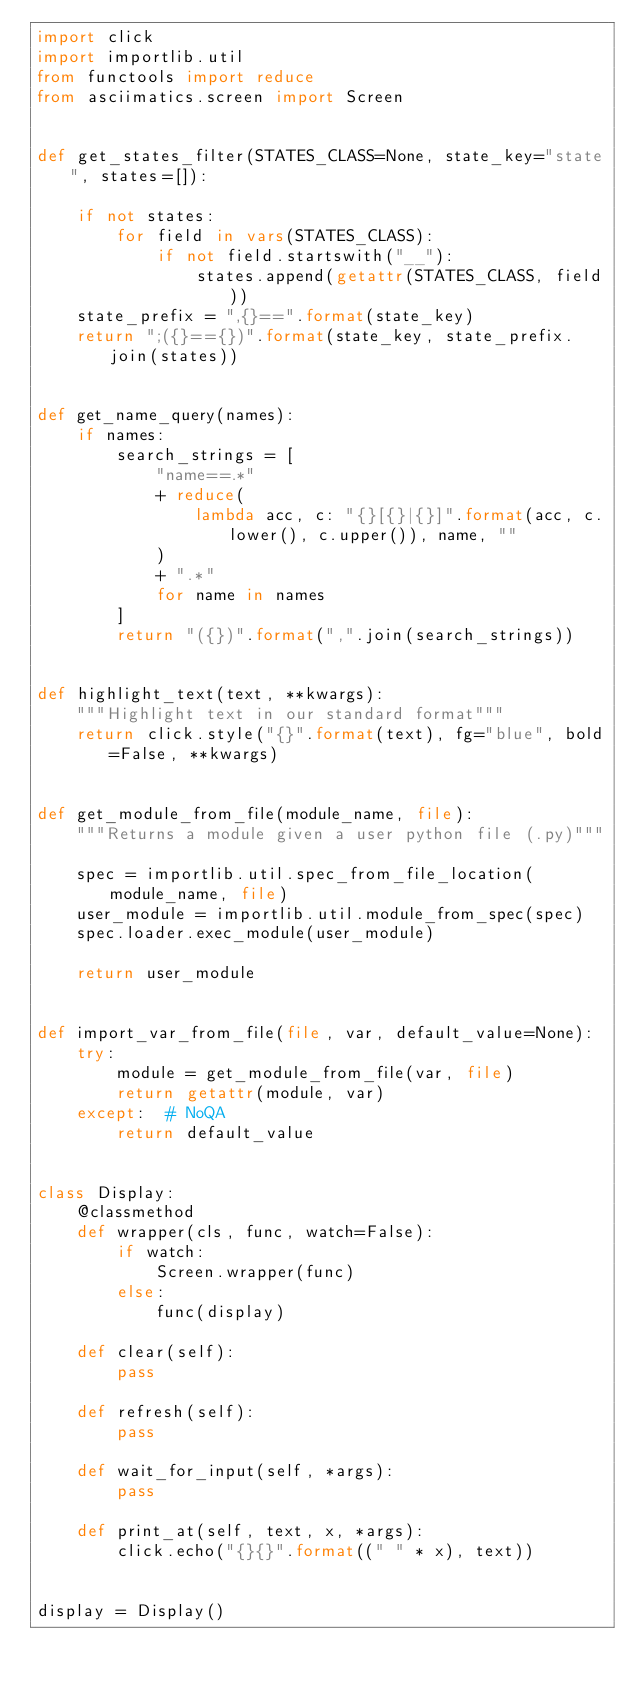Convert code to text. <code><loc_0><loc_0><loc_500><loc_500><_Python_>import click
import importlib.util
from functools import reduce
from asciimatics.screen import Screen


def get_states_filter(STATES_CLASS=None, state_key="state", states=[]):

    if not states:
        for field in vars(STATES_CLASS):
            if not field.startswith("__"):
                states.append(getattr(STATES_CLASS, field))
    state_prefix = ",{}==".format(state_key)
    return ";({}=={})".format(state_key, state_prefix.join(states))


def get_name_query(names):
    if names:
        search_strings = [
            "name==.*"
            + reduce(
                lambda acc, c: "{}[{}|{}]".format(acc, c.lower(), c.upper()), name, ""
            )
            + ".*"
            for name in names
        ]
        return "({})".format(",".join(search_strings))


def highlight_text(text, **kwargs):
    """Highlight text in our standard format"""
    return click.style("{}".format(text), fg="blue", bold=False, **kwargs)


def get_module_from_file(module_name, file):
    """Returns a module given a user python file (.py)"""

    spec = importlib.util.spec_from_file_location(module_name, file)
    user_module = importlib.util.module_from_spec(spec)
    spec.loader.exec_module(user_module)

    return user_module


def import_var_from_file(file, var, default_value=None):
    try:
        module = get_module_from_file(var, file)
        return getattr(module, var)
    except:  # NoQA
        return default_value


class Display:
    @classmethod
    def wrapper(cls, func, watch=False):
        if watch:
            Screen.wrapper(func)
        else:
            func(display)

    def clear(self):
        pass

    def refresh(self):
        pass

    def wait_for_input(self, *args):
        pass

    def print_at(self, text, x, *args):
        click.echo("{}{}".format((" " * x), text))


display = Display()
</code> 